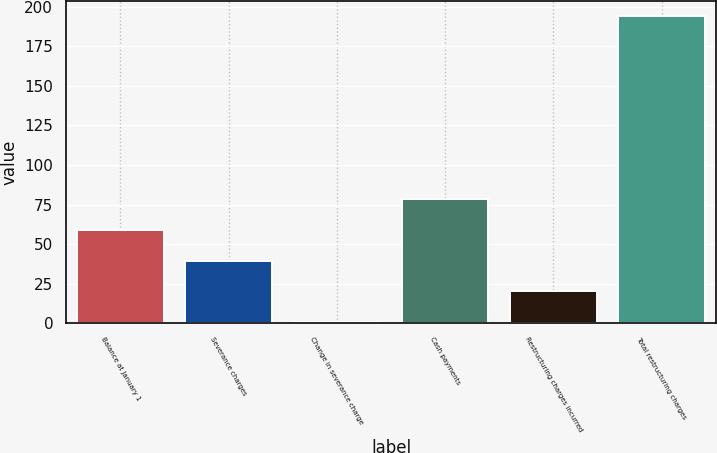<chart> <loc_0><loc_0><loc_500><loc_500><bar_chart><fcel>Balance at January 1<fcel>Severance charges<fcel>Change in severance charge<fcel>Cash payments<fcel>Restructuring charges incurred<fcel>Total restructuring charges<nl><fcel>58.9<fcel>39.6<fcel>1<fcel>78.2<fcel>20.3<fcel>194<nl></chart> 